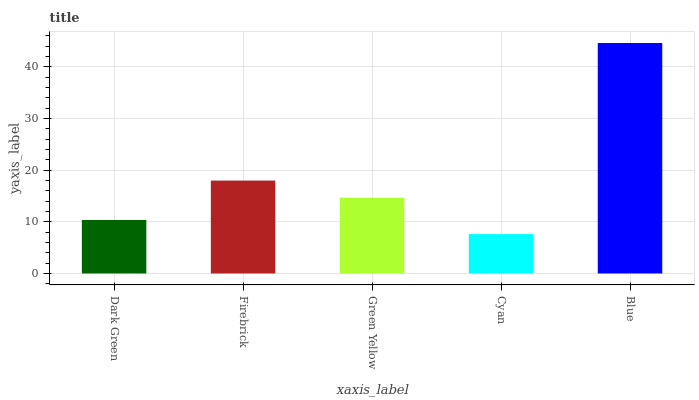Is Cyan the minimum?
Answer yes or no. Yes. Is Blue the maximum?
Answer yes or no. Yes. Is Firebrick the minimum?
Answer yes or no. No. Is Firebrick the maximum?
Answer yes or no. No. Is Firebrick greater than Dark Green?
Answer yes or no. Yes. Is Dark Green less than Firebrick?
Answer yes or no. Yes. Is Dark Green greater than Firebrick?
Answer yes or no. No. Is Firebrick less than Dark Green?
Answer yes or no. No. Is Green Yellow the high median?
Answer yes or no. Yes. Is Green Yellow the low median?
Answer yes or no. Yes. Is Blue the high median?
Answer yes or no. No. Is Blue the low median?
Answer yes or no. No. 